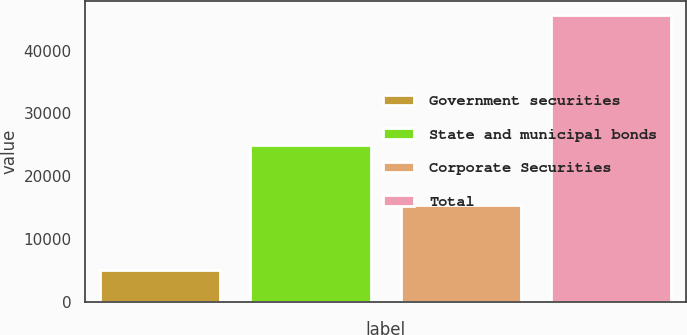Convert chart. <chart><loc_0><loc_0><loc_500><loc_500><bar_chart><fcel>Government securities<fcel>State and municipal bonds<fcel>Corporate Securities<fcel>Total<nl><fcel>5179<fcel>24969<fcel>15429<fcel>45577<nl></chart> 